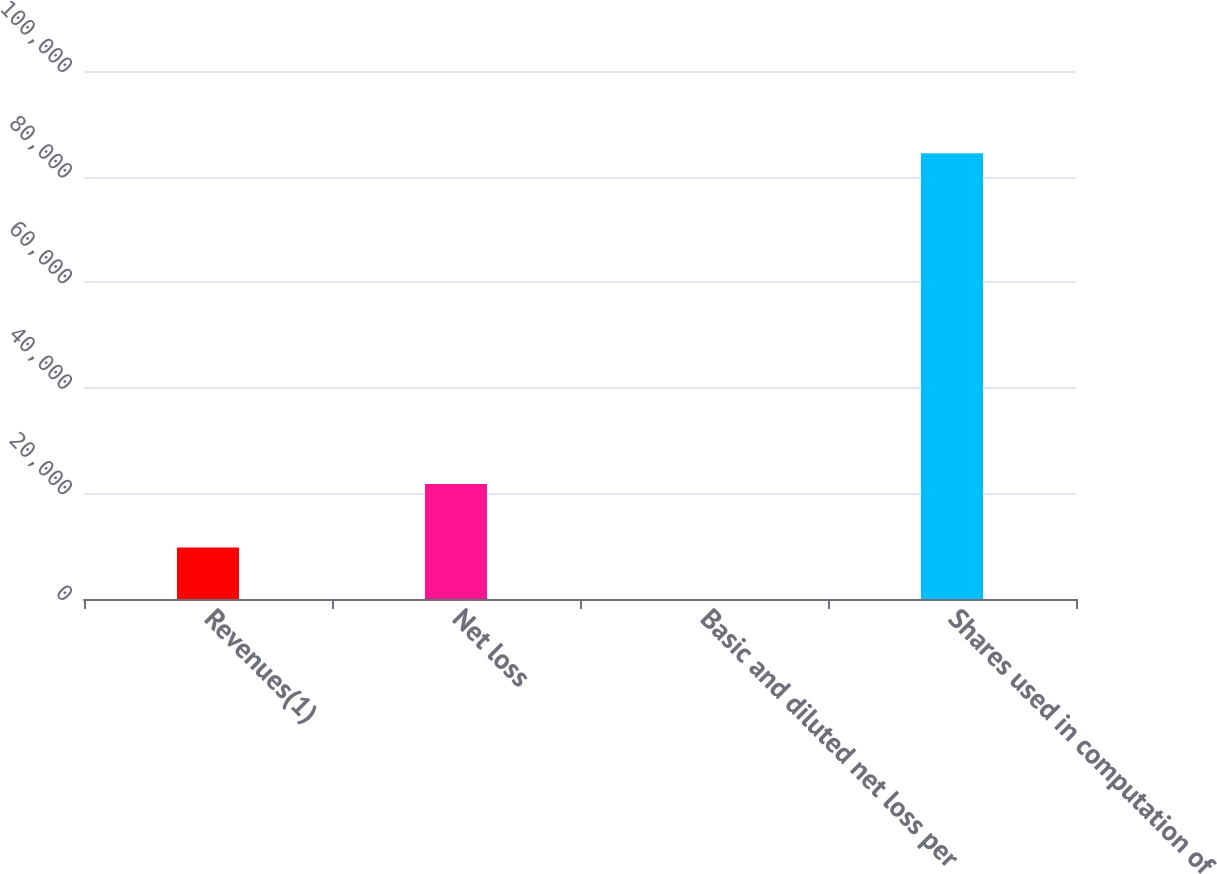<chart> <loc_0><loc_0><loc_500><loc_500><bar_chart><fcel>Revenues(1)<fcel>Net loss<fcel>Basic and diluted net loss per<fcel>Shares used in computation of<nl><fcel>9752<fcel>21801<fcel>0.26<fcel>84405<nl></chart> 